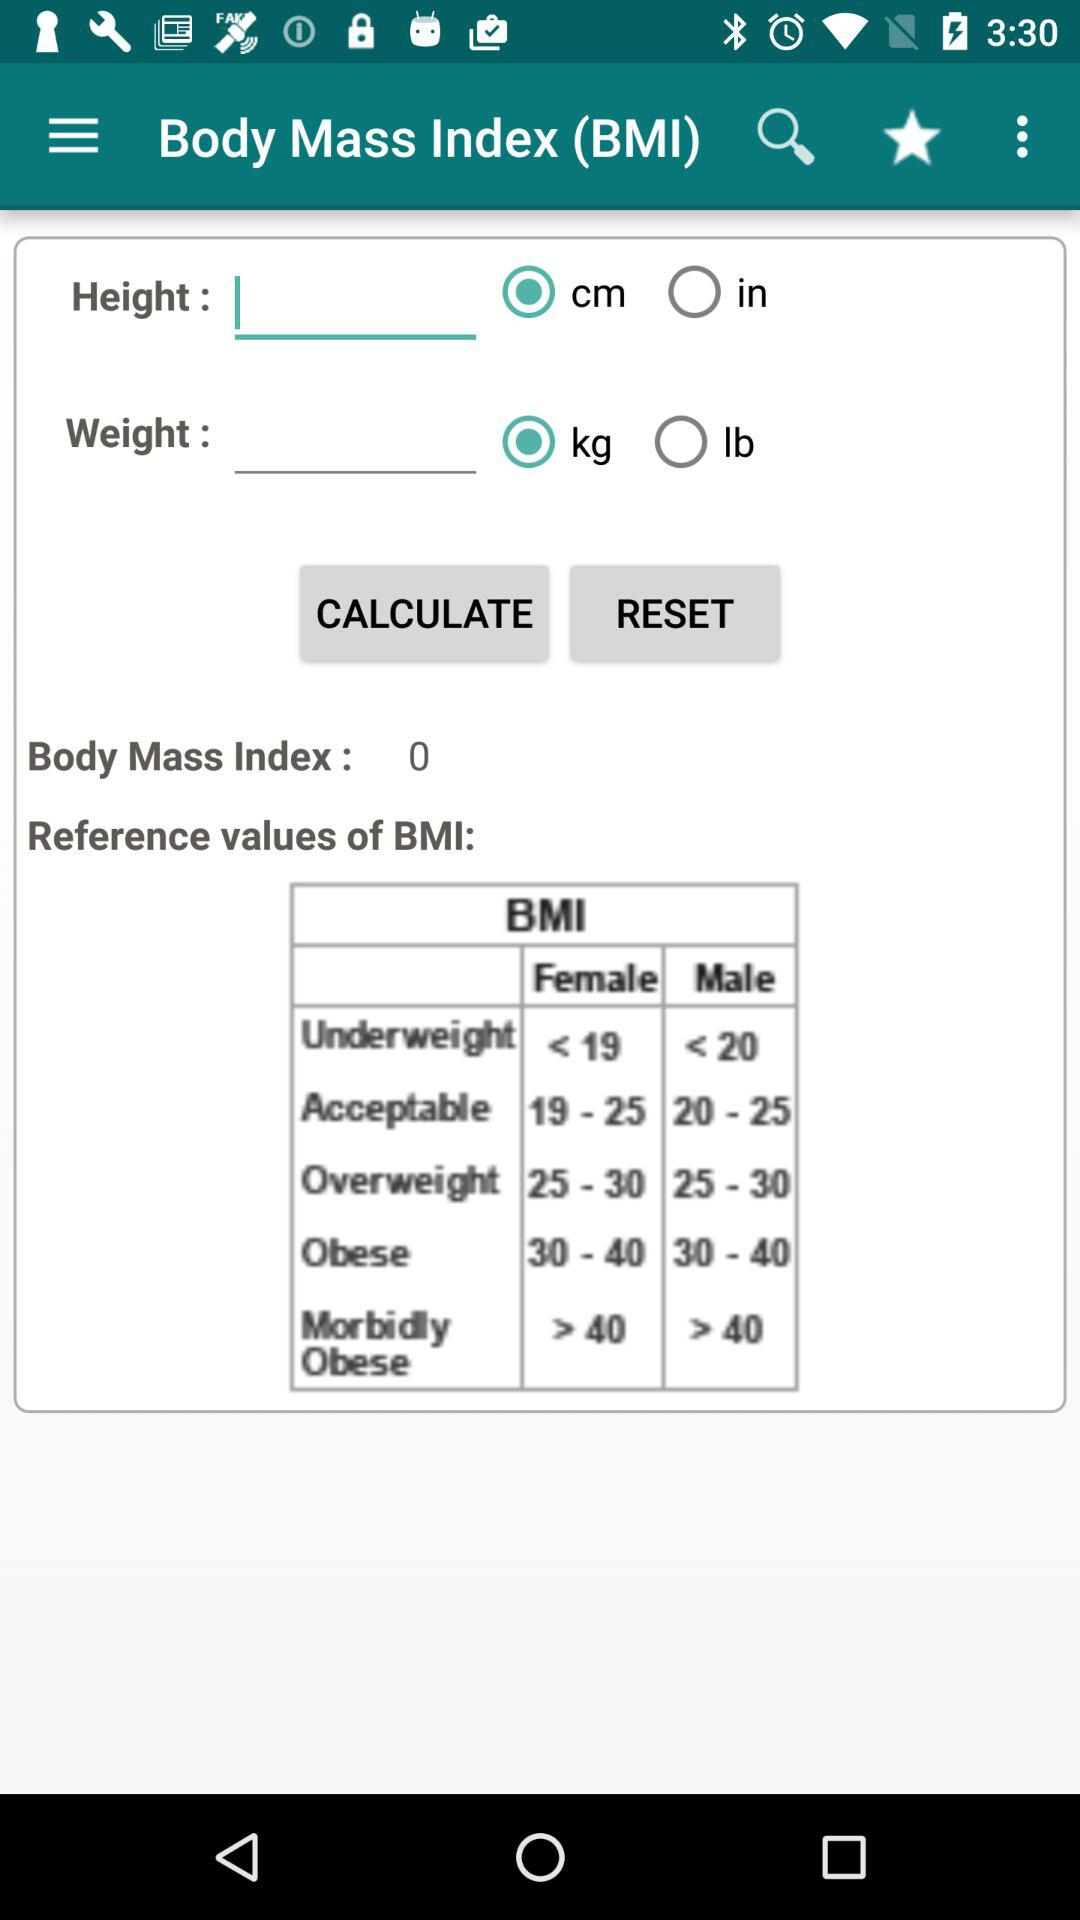Is "cm" selected or not?
Answer the question using a single word or phrase. "cm" is selected. 